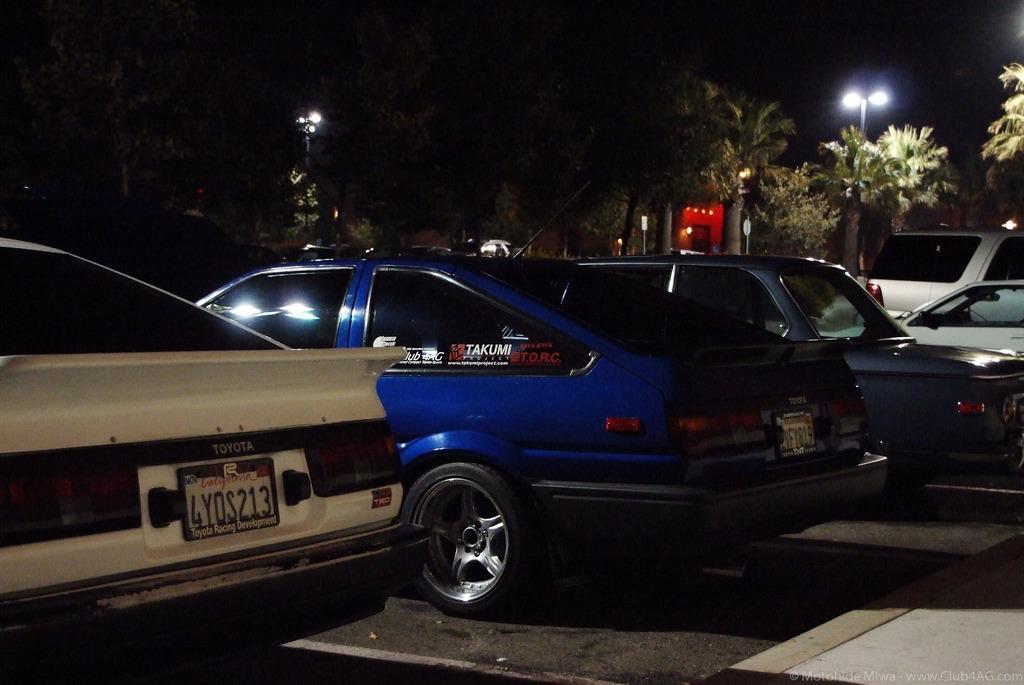Can you describe this image briefly? In the middle of the image there are some vehicles. Behind the vehicles there are some trees and poles. 